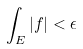Convert formula to latex. <formula><loc_0><loc_0><loc_500><loc_500>\int _ { E } | f | < \epsilon</formula> 